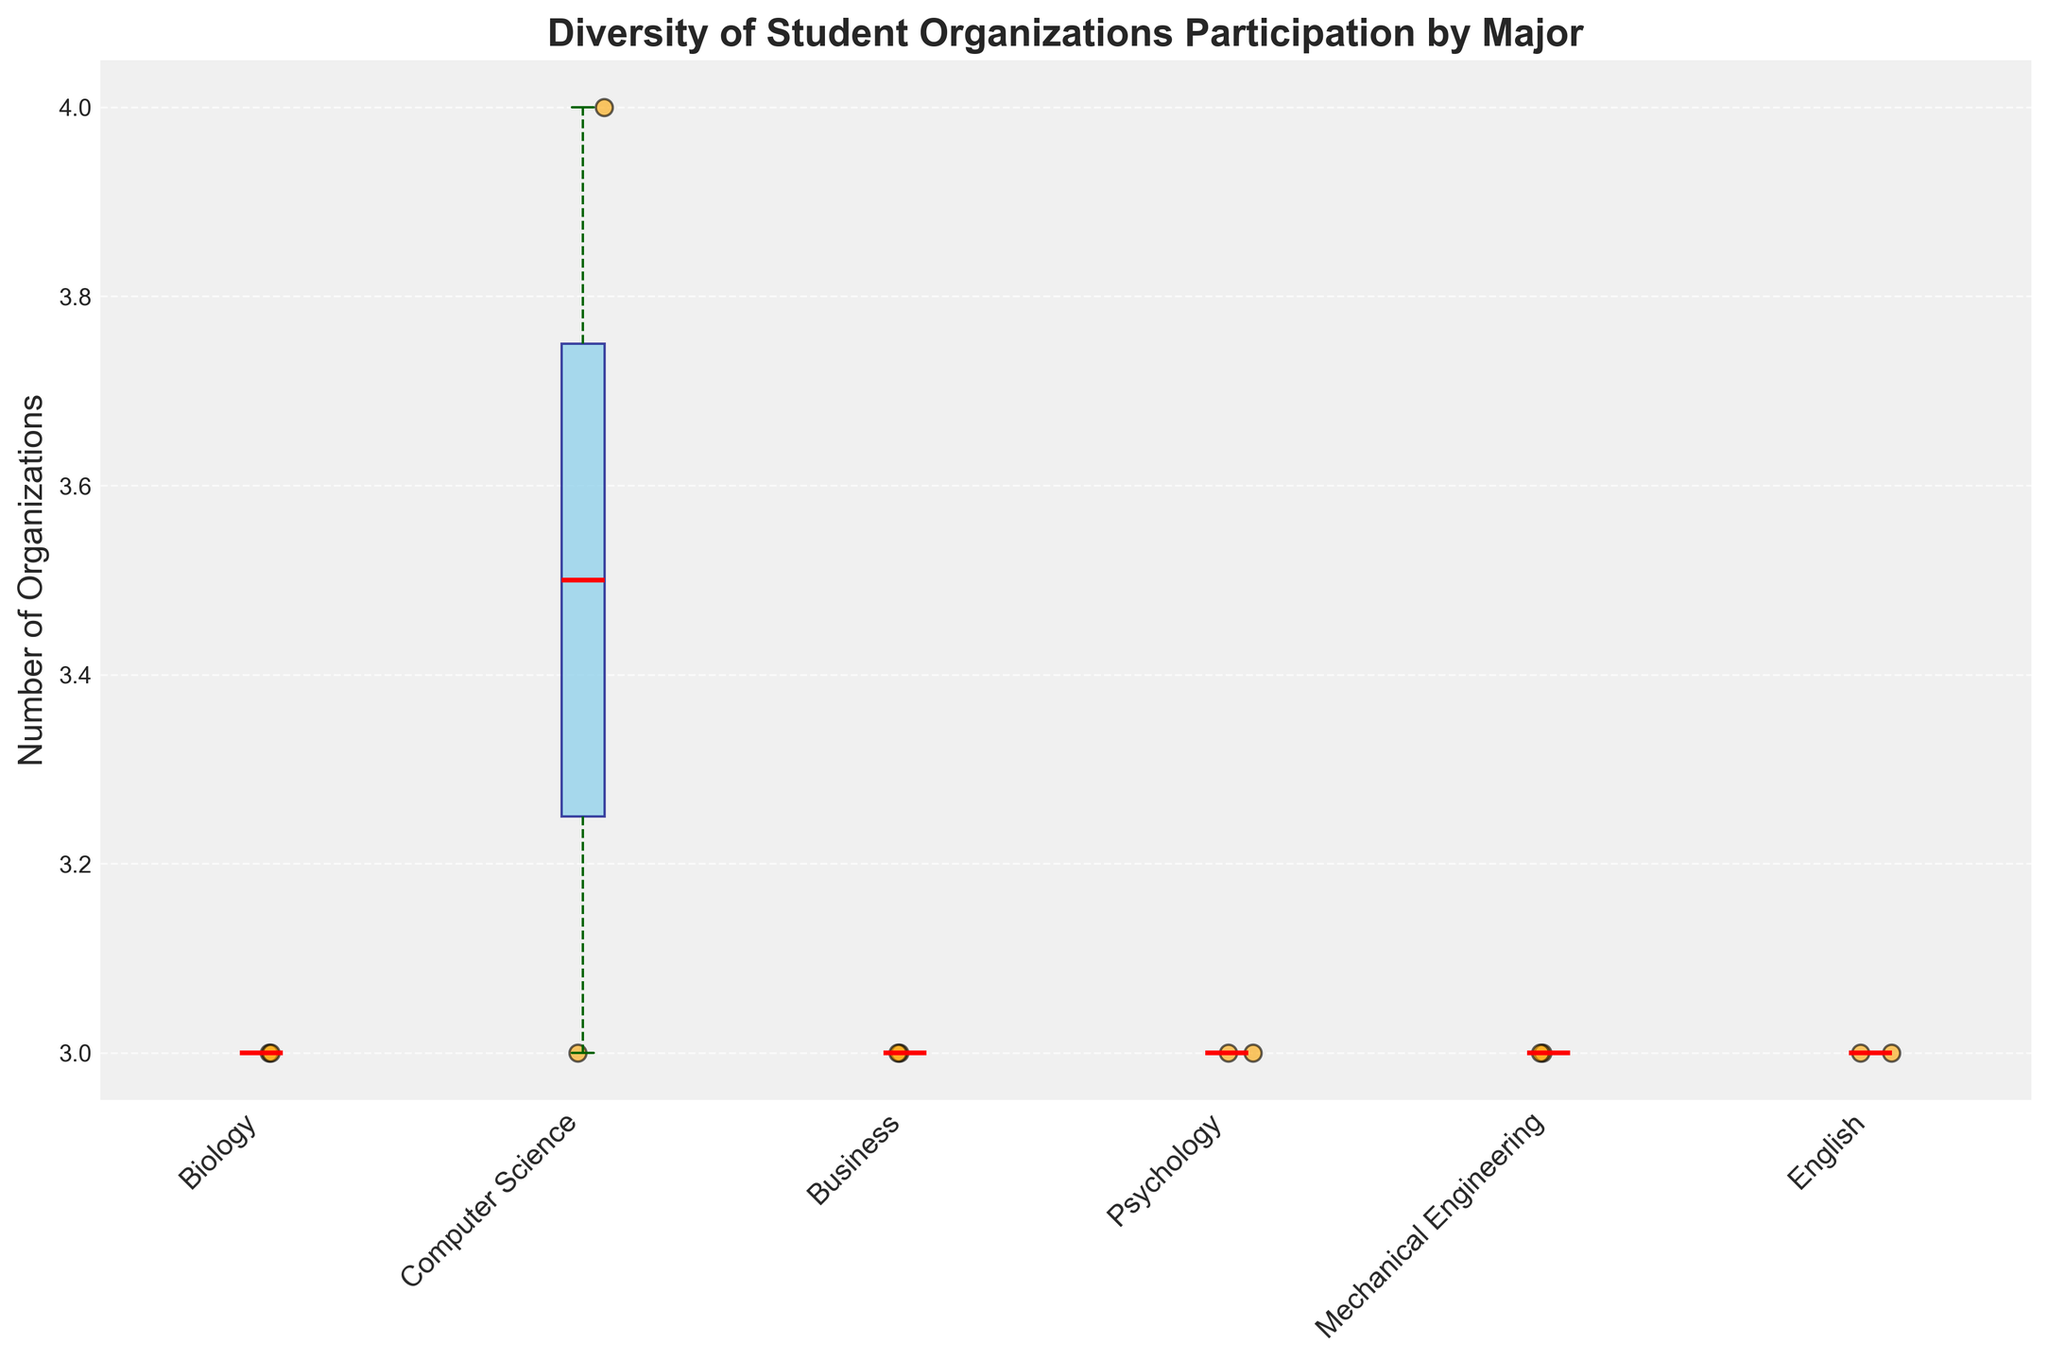What is the title of the plot? The title is displayed prominently at the top of the figure.
Answer: "Diversity of Student Organizations Participation by Major" What does the y-axis represent? The label on the y-axis indicates it measures the number of organizations students participate in.
Answer: "Number of Organizations" Which major has the widest box plot? By examining the widths of each box plot, observe that the box for Biology is the widest.
Answer: Biology How many majors are compared in this plot? Count the distinct labels on the x-axis.
Answer: 6 What is the median number of organizations for Business students? The median is represented by the red line inside the box for Business.
Answer: 2 Which major shows the highest variability in student participation in organizations? The major with the largest interquartile range (IQR), which is the length of the box, indicates higher variability.
Answer: Psychology How does the average number of organizations for Computer Science students compare to that of English students? Compare the positions of the mean values as represented by the scatter plots around the boxes. The average is visually positioned higher for Computer Science than English.
Answer: Higher for Computer Science What unique feature of the plot helps in visualizing the number of students in each major? The width of each box plot represents the proportion of students belonging to each major.
Answer: Width of the box plot How many organizations do the median Biology students participate in? The red median line inside the Biology box plot indicates this value.
Answer: 2 Among Mechanical Engineering and English students, which group participates in a higher maximum number of organizations? Examine the upper whisker and the highest data points for both Mechanical Engineering and English. Mechanical Engineering students have a higher maximum value.
Answer: Mechanical Engineering 